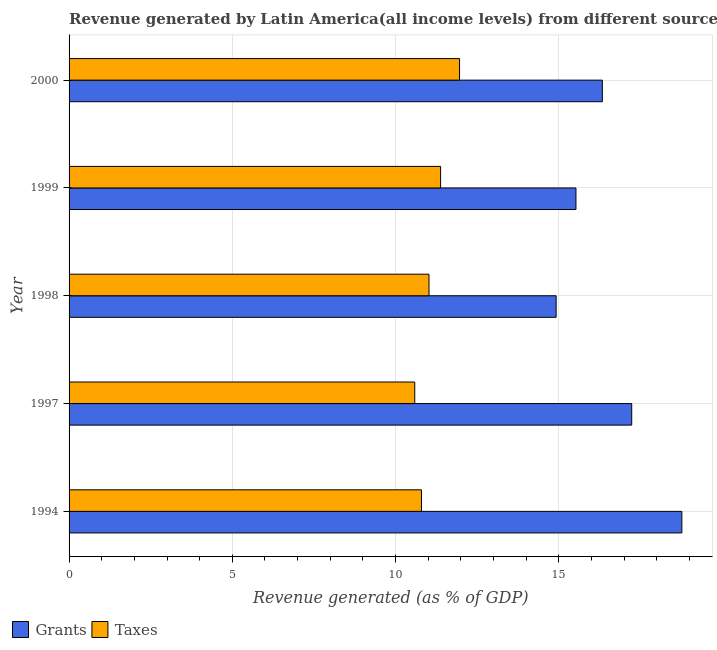Are the number of bars per tick equal to the number of legend labels?
Keep it short and to the point. Yes. How many bars are there on the 1st tick from the top?
Give a very brief answer. 2. What is the label of the 3rd group of bars from the top?
Offer a very short reply. 1998. What is the revenue generated by taxes in 1997?
Keep it short and to the point. 10.59. Across all years, what is the maximum revenue generated by grants?
Your response must be concise. 18.77. Across all years, what is the minimum revenue generated by taxes?
Ensure brevity in your answer.  10.59. In which year was the revenue generated by grants minimum?
Your answer should be very brief. 1998. What is the total revenue generated by taxes in the graph?
Give a very brief answer. 55.75. What is the difference between the revenue generated by taxes in 1994 and that in 1998?
Make the answer very short. -0.23. What is the difference between the revenue generated by taxes in 1998 and the revenue generated by grants in 1997?
Keep it short and to the point. -6.21. What is the average revenue generated by taxes per year?
Offer a very short reply. 11.15. In the year 1998, what is the difference between the revenue generated by grants and revenue generated by taxes?
Provide a succinct answer. 3.9. In how many years, is the revenue generated by grants greater than 11 %?
Your response must be concise. 5. What is the ratio of the revenue generated by grants in 1994 to that in 2000?
Your answer should be very brief. 1.15. Is the difference between the revenue generated by taxes in 1998 and 2000 greater than the difference between the revenue generated by grants in 1998 and 2000?
Offer a very short reply. Yes. What is the difference between the highest and the second highest revenue generated by taxes?
Offer a terse response. 0.58. What is the difference between the highest and the lowest revenue generated by grants?
Provide a succinct answer. 3.85. In how many years, is the revenue generated by taxes greater than the average revenue generated by taxes taken over all years?
Offer a very short reply. 2. What does the 1st bar from the top in 1999 represents?
Provide a short and direct response. Taxes. What does the 1st bar from the bottom in 1997 represents?
Give a very brief answer. Grants. How many bars are there?
Offer a terse response. 10. What is the difference between two consecutive major ticks on the X-axis?
Your answer should be compact. 5. Does the graph contain grids?
Ensure brevity in your answer.  Yes. Where does the legend appear in the graph?
Your answer should be compact. Bottom left. How many legend labels are there?
Offer a terse response. 2. How are the legend labels stacked?
Ensure brevity in your answer.  Horizontal. What is the title of the graph?
Provide a succinct answer. Revenue generated by Latin America(all income levels) from different sources. What is the label or title of the X-axis?
Your answer should be compact. Revenue generated (as % of GDP). What is the Revenue generated (as % of GDP) in Grants in 1994?
Offer a terse response. 18.77. What is the Revenue generated (as % of GDP) in Taxes in 1994?
Offer a terse response. 10.8. What is the Revenue generated (as % of GDP) in Grants in 1997?
Offer a terse response. 17.24. What is the Revenue generated (as % of GDP) in Taxes in 1997?
Provide a short and direct response. 10.59. What is the Revenue generated (as % of GDP) in Grants in 1998?
Your answer should be compact. 14.92. What is the Revenue generated (as % of GDP) in Taxes in 1998?
Provide a succinct answer. 11.03. What is the Revenue generated (as % of GDP) of Grants in 1999?
Provide a short and direct response. 15.53. What is the Revenue generated (as % of GDP) of Taxes in 1999?
Provide a succinct answer. 11.38. What is the Revenue generated (as % of GDP) in Grants in 2000?
Provide a short and direct response. 16.34. What is the Revenue generated (as % of GDP) of Taxes in 2000?
Ensure brevity in your answer.  11.96. Across all years, what is the maximum Revenue generated (as % of GDP) of Grants?
Give a very brief answer. 18.77. Across all years, what is the maximum Revenue generated (as % of GDP) in Taxes?
Provide a succinct answer. 11.96. Across all years, what is the minimum Revenue generated (as % of GDP) of Grants?
Provide a short and direct response. 14.92. Across all years, what is the minimum Revenue generated (as % of GDP) in Taxes?
Ensure brevity in your answer.  10.59. What is the total Revenue generated (as % of GDP) of Grants in the graph?
Your answer should be compact. 82.79. What is the total Revenue generated (as % of GDP) in Taxes in the graph?
Offer a terse response. 55.75. What is the difference between the Revenue generated (as % of GDP) in Grants in 1994 and that in 1997?
Offer a terse response. 1.54. What is the difference between the Revenue generated (as % of GDP) of Taxes in 1994 and that in 1997?
Your answer should be very brief. 0.21. What is the difference between the Revenue generated (as % of GDP) in Grants in 1994 and that in 1998?
Provide a short and direct response. 3.85. What is the difference between the Revenue generated (as % of GDP) in Taxes in 1994 and that in 1998?
Make the answer very short. -0.23. What is the difference between the Revenue generated (as % of GDP) of Grants in 1994 and that in 1999?
Your answer should be compact. 3.24. What is the difference between the Revenue generated (as % of GDP) of Taxes in 1994 and that in 1999?
Keep it short and to the point. -0.59. What is the difference between the Revenue generated (as % of GDP) of Grants in 1994 and that in 2000?
Offer a very short reply. 2.44. What is the difference between the Revenue generated (as % of GDP) of Taxes in 1994 and that in 2000?
Offer a terse response. -1.17. What is the difference between the Revenue generated (as % of GDP) of Grants in 1997 and that in 1998?
Make the answer very short. 2.32. What is the difference between the Revenue generated (as % of GDP) of Taxes in 1997 and that in 1998?
Your response must be concise. -0.44. What is the difference between the Revenue generated (as % of GDP) of Grants in 1997 and that in 1999?
Give a very brief answer. 1.71. What is the difference between the Revenue generated (as % of GDP) in Taxes in 1997 and that in 1999?
Make the answer very short. -0.79. What is the difference between the Revenue generated (as % of GDP) of Grants in 1997 and that in 2000?
Ensure brevity in your answer.  0.9. What is the difference between the Revenue generated (as % of GDP) in Taxes in 1997 and that in 2000?
Your answer should be compact. -1.37. What is the difference between the Revenue generated (as % of GDP) in Grants in 1998 and that in 1999?
Ensure brevity in your answer.  -0.61. What is the difference between the Revenue generated (as % of GDP) of Taxes in 1998 and that in 1999?
Ensure brevity in your answer.  -0.35. What is the difference between the Revenue generated (as % of GDP) of Grants in 1998 and that in 2000?
Offer a very short reply. -1.42. What is the difference between the Revenue generated (as % of GDP) of Taxes in 1998 and that in 2000?
Provide a succinct answer. -0.94. What is the difference between the Revenue generated (as % of GDP) in Grants in 1999 and that in 2000?
Offer a terse response. -0.81. What is the difference between the Revenue generated (as % of GDP) in Taxes in 1999 and that in 2000?
Offer a terse response. -0.58. What is the difference between the Revenue generated (as % of GDP) in Grants in 1994 and the Revenue generated (as % of GDP) in Taxes in 1997?
Provide a short and direct response. 8.18. What is the difference between the Revenue generated (as % of GDP) of Grants in 1994 and the Revenue generated (as % of GDP) of Taxes in 1998?
Provide a short and direct response. 7.75. What is the difference between the Revenue generated (as % of GDP) in Grants in 1994 and the Revenue generated (as % of GDP) in Taxes in 1999?
Provide a succinct answer. 7.39. What is the difference between the Revenue generated (as % of GDP) of Grants in 1994 and the Revenue generated (as % of GDP) of Taxes in 2000?
Offer a very short reply. 6.81. What is the difference between the Revenue generated (as % of GDP) in Grants in 1997 and the Revenue generated (as % of GDP) in Taxes in 1998?
Make the answer very short. 6.21. What is the difference between the Revenue generated (as % of GDP) of Grants in 1997 and the Revenue generated (as % of GDP) of Taxes in 1999?
Your response must be concise. 5.86. What is the difference between the Revenue generated (as % of GDP) of Grants in 1997 and the Revenue generated (as % of GDP) of Taxes in 2000?
Offer a very short reply. 5.27. What is the difference between the Revenue generated (as % of GDP) in Grants in 1998 and the Revenue generated (as % of GDP) in Taxes in 1999?
Offer a very short reply. 3.54. What is the difference between the Revenue generated (as % of GDP) in Grants in 1998 and the Revenue generated (as % of GDP) in Taxes in 2000?
Your answer should be very brief. 2.96. What is the difference between the Revenue generated (as % of GDP) of Grants in 1999 and the Revenue generated (as % of GDP) of Taxes in 2000?
Your response must be concise. 3.57. What is the average Revenue generated (as % of GDP) of Grants per year?
Your answer should be compact. 16.56. What is the average Revenue generated (as % of GDP) in Taxes per year?
Give a very brief answer. 11.15. In the year 1994, what is the difference between the Revenue generated (as % of GDP) in Grants and Revenue generated (as % of GDP) in Taxes?
Offer a terse response. 7.98. In the year 1997, what is the difference between the Revenue generated (as % of GDP) in Grants and Revenue generated (as % of GDP) in Taxes?
Provide a succinct answer. 6.65. In the year 1998, what is the difference between the Revenue generated (as % of GDP) of Grants and Revenue generated (as % of GDP) of Taxes?
Give a very brief answer. 3.89. In the year 1999, what is the difference between the Revenue generated (as % of GDP) of Grants and Revenue generated (as % of GDP) of Taxes?
Ensure brevity in your answer.  4.15. In the year 2000, what is the difference between the Revenue generated (as % of GDP) of Grants and Revenue generated (as % of GDP) of Taxes?
Your answer should be very brief. 4.38. What is the ratio of the Revenue generated (as % of GDP) in Grants in 1994 to that in 1997?
Your response must be concise. 1.09. What is the ratio of the Revenue generated (as % of GDP) of Taxes in 1994 to that in 1997?
Keep it short and to the point. 1.02. What is the ratio of the Revenue generated (as % of GDP) of Grants in 1994 to that in 1998?
Your answer should be very brief. 1.26. What is the ratio of the Revenue generated (as % of GDP) in Grants in 1994 to that in 1999?
Your answer should be compact. 1.21. What is the ratio of the Revenue generated (as % of GDP) in Taxes in 1994 to that in 1999?
Provide a short and direct response. 0.95. What is the ratio of the Revenue generated (as % of GDP) of Grants in 1994 to that in 2000?
Your answer should be compact. 1.15. What is the ratio of the Revenue generated (as % of GDP) of Taxes in 1994 to that in 2000?
Ensure brevity in your answer.  0.9. What is the ratio of the Revenue generated (as % of GDP) in Grants in 1997 to that in 1998?
Offer a very short reply. 1.16. What is the ratio of the Revenue generated (as % of GDP) in Taxes in 1997 to that in 1998?
Provide a short and direct response. 0.96. What is the ratio of the Revenue generated (as % of GDP) in Grants in 1997 to that in 1999?
Provide a short and direct response. 1.11. What is the ratio of the Revenue generated (as % of GDP) of Taxes in 1997 to that in 1999?
Your answer should be very brief. 0.93. What is the ratio of the Revenue generated (as % of GDP) of Grants in 1997 to that in 2000?
Your answer should be compact. 1.06. What is the ratio of the Revenue generated (as % of GDP) of Taxes in 1997 to that in 2000?
Your response must be concise. 0.89. What is the ratio of the Revenue generated (as % of GDP) of Grants in 1998 to that in 1999?
Make the answer very short. 0.96. What is the ratio of the Revenue generated (as % of GDP) in Taxes in 1998 to that in 1999?
Your answer should be compact. 0.97. What is the ratio of the Revenue generated (as % of GDP) of Grants in 1998 to that in 2000?
Ensure brevity in your answer.  0.91. What is the ratio of the Revenue generated (as % of GDP) in Taxes in 1998 to that in 2000?
Provide a short and direct response. 0.92. What is the ratio of the Revenue generated (as % of GDP) in Grants in 1999 to that in 2000?
Provide a succinct answer. 0.95. What is the ratio of the Revenue generated (as % of GDP) of Taxes in 1999 to that in 2000?
Make the answer very short. 0.95. What is the difference between the highest and the second highest Revenue generated (as % of GDP) of Grants?
Make the answer very short. 1.54. What is the difference between the highest and the second highest Revenue generated (as % of GDP) in Taxes?
Keep it short and to the point. 0.58. What is the difference between the highest and the lowest Revenue generated (as % of GDP) in Grants?
Your response must be concise. 3.85. What is the difference between the highest and the lowest Revenue generated (as % of GDP) in Taxes?
Give a very brief answer. 1.37. 